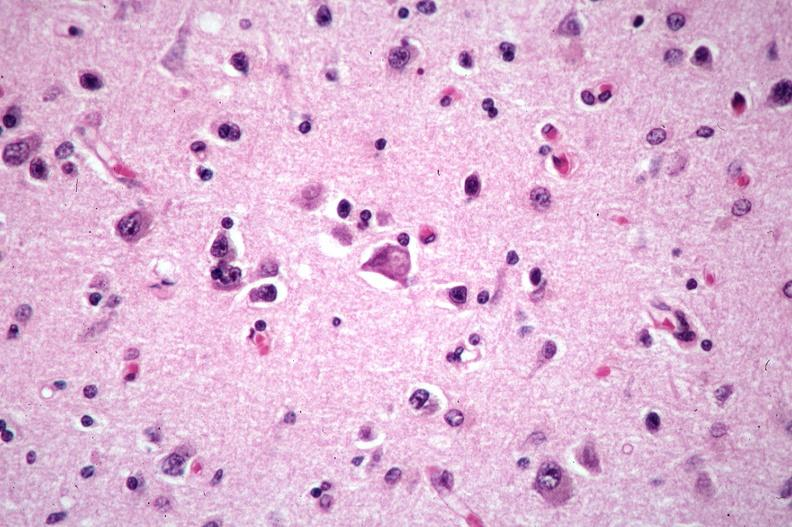does this image show brain, pick 's disease?
Answer the question using a single word or phrase. Yes 